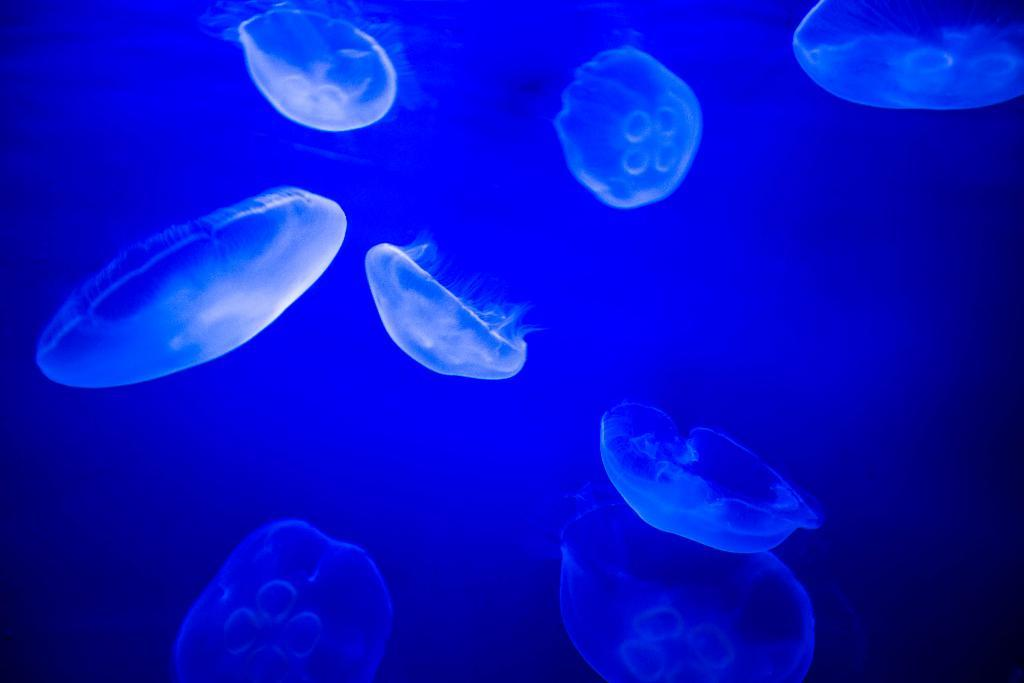What can be seen in the background of the image? There is an undefined object in the background of the image. What color is visible in the image? The color blue is present in the image. Can you describe the dog's fur color in the image? There is no dog present in the image, so we cannot describe its fur color. 